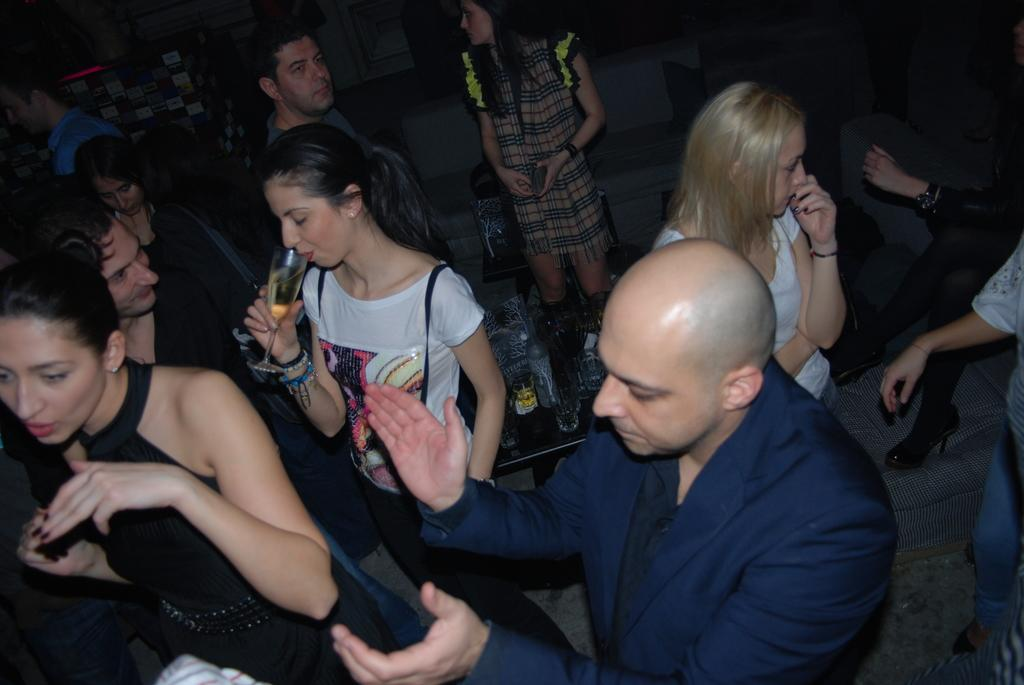What are the people in the image doing? The people in the image are standing. What are some people holding in the image? Some people are holding glasses in the image. What can be seen on the table in the image? There are objects on the table in the image. How can you describe the clothing of the people in the image? The people are wearing different color dresses in the image. How many horses are present in the image? There are no horses present in the image. What letter is being passed around among the people in the image? There is no letter being passed around among the people in the image. 